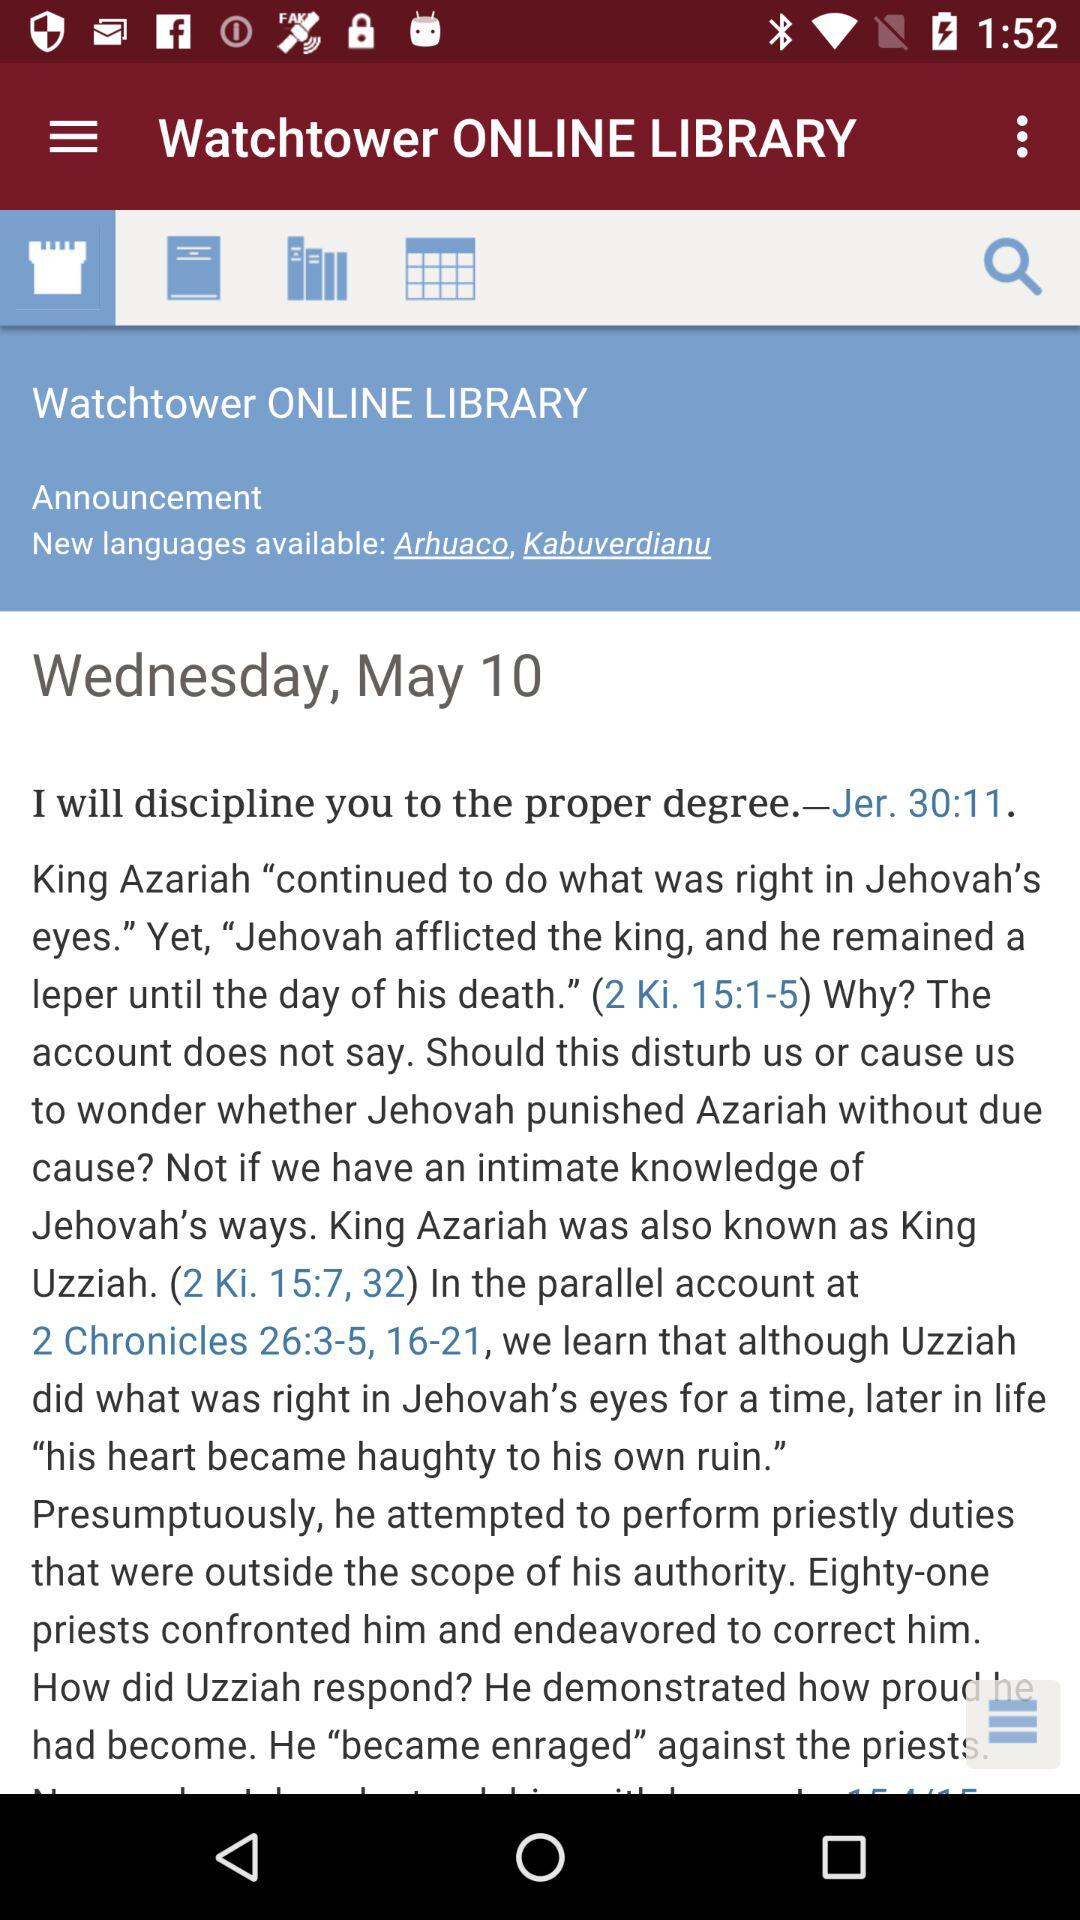What are the available new languages? The available new languages are Arhuaco and Kabuverdianu. 